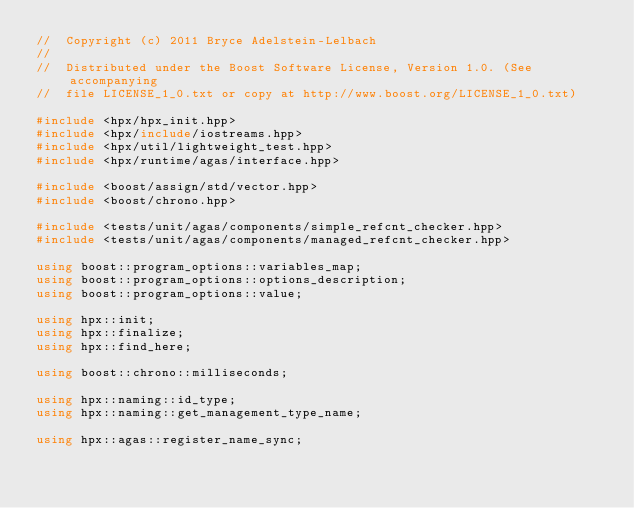<code> <loc_0><loc_0><loc_500><loc_500><_C++_>//  Copyright (c) 2011 Bryce Adelstein-Lelbach
//
//  Distributed under the Boost Software License, Version 1.0. (See accompanying
//  file LICENSE_1_0.txt or copy at http://www.boost.org/LICENSE_1_0.txt)

#include <hpx/hpx_init.hpp>
#include <hpx/include/iostreams.hpp>
#include <hpx/util/lightweight_test.hpp>
#include <hpx/runtime/agas/interface.hpp>

#include <boost/assign/std/vector.hpp>
#include <boost/chrono.hpp>

#include <tests/unit/agas/components/simple_refcnt_checker.hpp>
#include <tests/unit/agas/components/managed_refcnt_checker.hpp>

using boost::program_options::variables_map;
using boost::program_options::options_description;
using boost::program_options::value;

using hpx::init;
using hpx::finalize;
using hpx::find_here;

using boost::chrono::milliseconds;

using hpx::naming::id_type;
using hpx::naming::get_management_type_name;

using hpx::agas::register_name_sync;</code> 